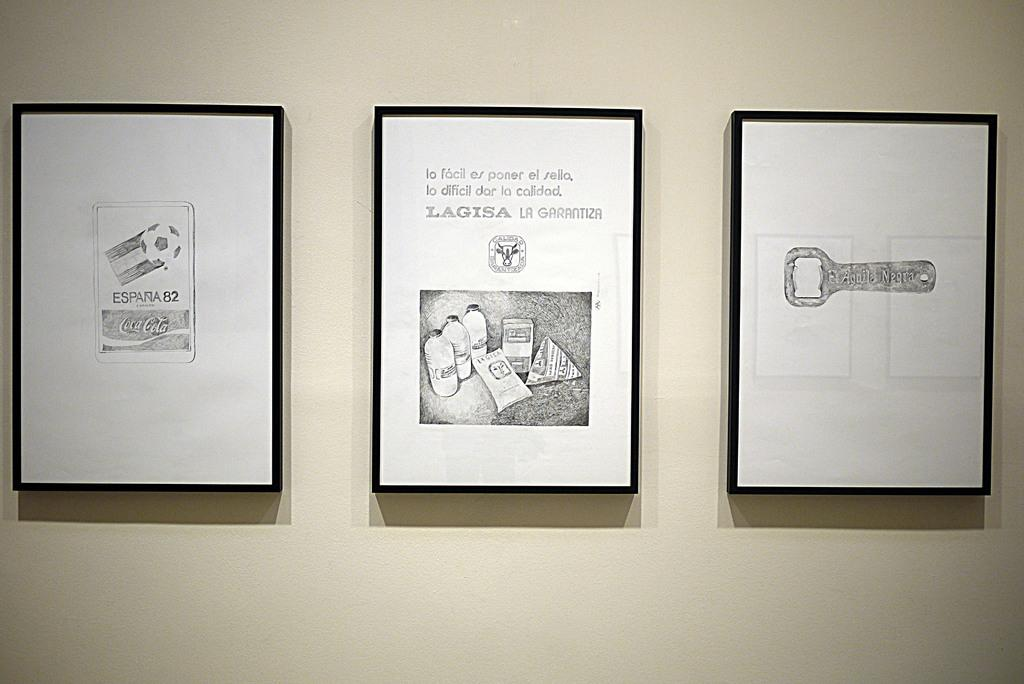<image>
Offer a succinct explanation of the picture presented. Three drawings on the wall with one looking as if it is a Coca Cola ad. 